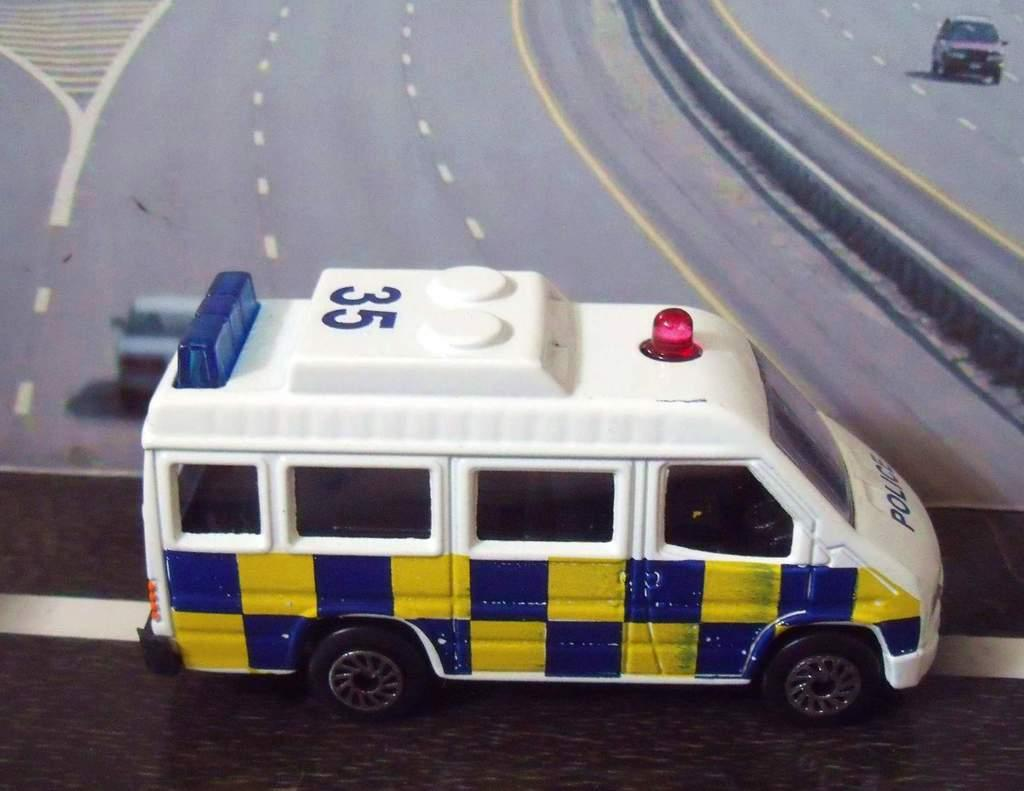What object is placed on a surface in the image? There is a toy placed on a surface in the image. What can be seen in the background of the image? In the background of the image, there is a picture. What is depicted in the picture? The picture contains vehicles parked on the ground and a crash barrier. How does the toy treat the wound in the image? There is no wound present in the image, and the toy is not treating any wound. 